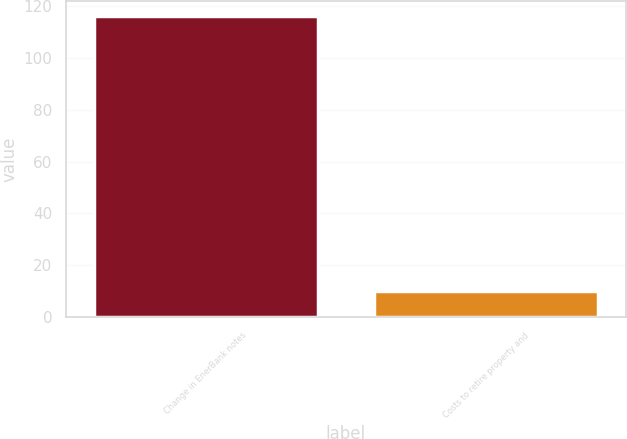Convert chart. <chart><loc_0><loc_0><loc_500><loc_500><bar_chart><fcel>Change in EnerBank notes<fcel>Costs to retire property and<nl><fcel>116<fcel>10<nl></chart> 